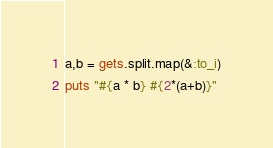<code> <loc_0><loc_0><loc_500><loc_500><_Ruby_>a,b = gets.split.map(&:to_i)
puts "#{a * b} #{2*(a+b)}"</code> 